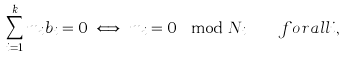<formula> <loc_0><loc_0><loc_500><loc_500>\sum _ { i = 1 } ^ { k } m _ { i } b _ { i } = 0 \iff m _ { i } = 0 \mod N _ { i } \quad f o r a l l i ,</formula> 